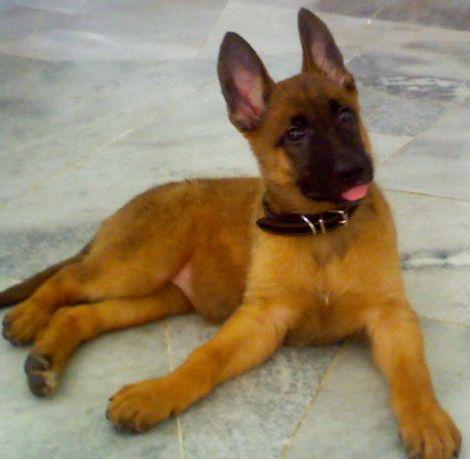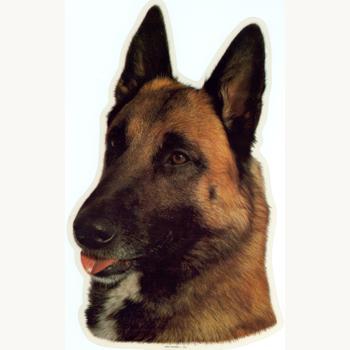The first image is the image on the left, the second image is the image on the right. Analyze the images presented: Is the assertion "An image shows a german shepherd wearing a collar." valid? Answer yes or no. Yes. 